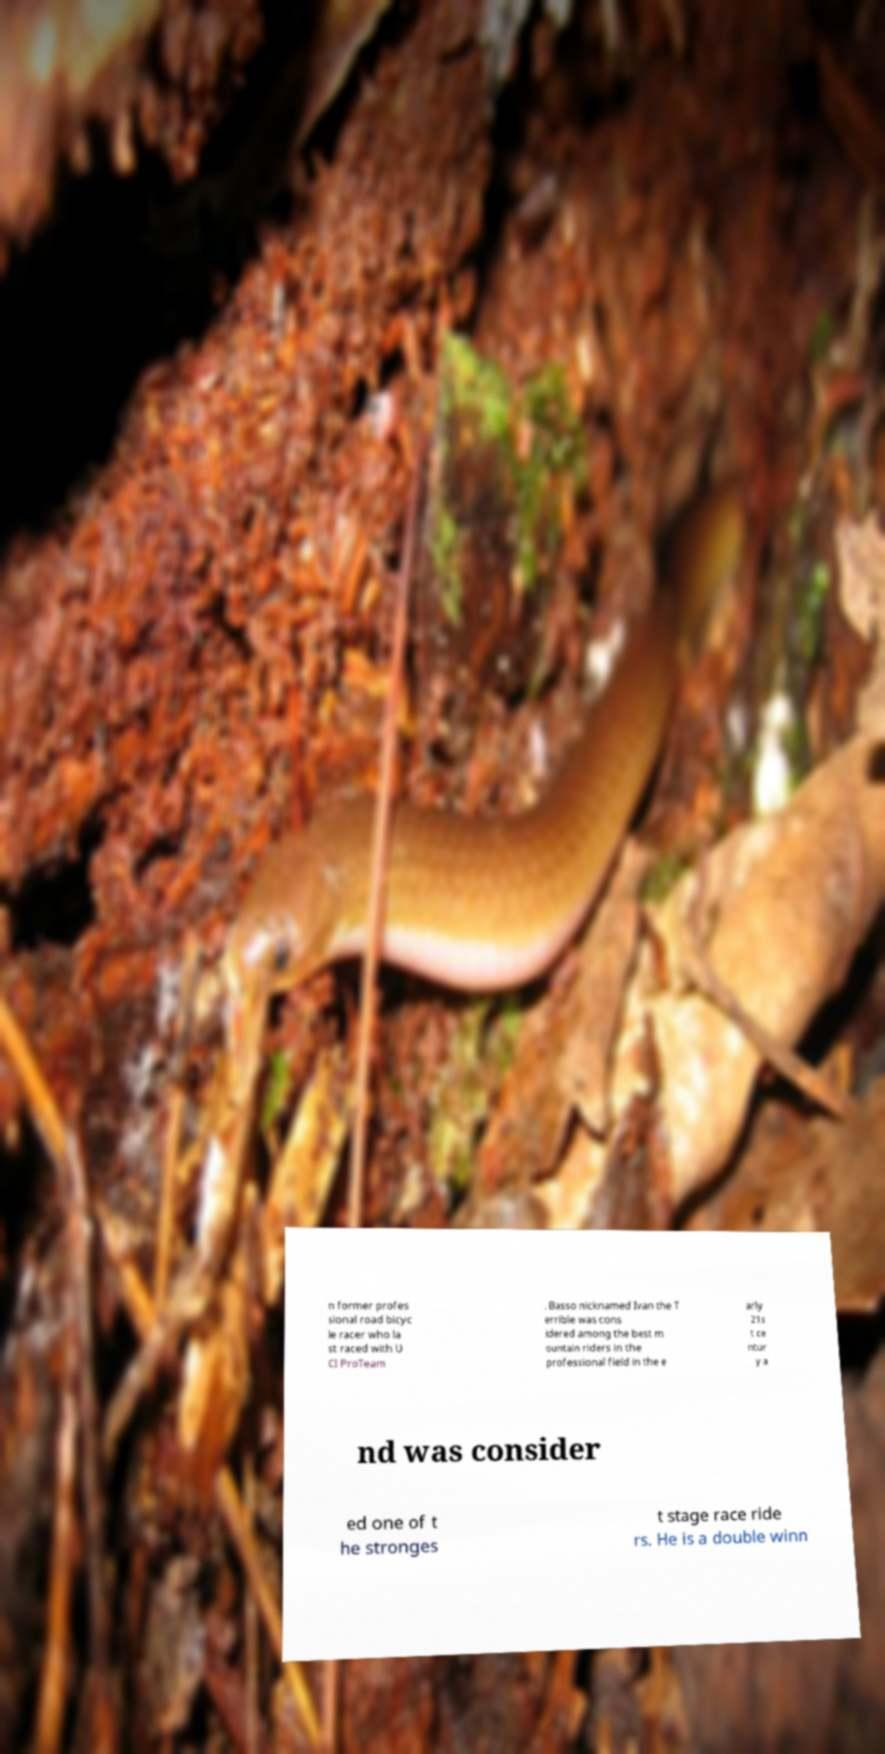For documentation purposes, I need the text within this image transcribed. Could you provide that? n former profes sional road bicyc le racer who la st raced with U CI ProTeam . Basso nicknamed Ivan the T errible was cons idered among the best m ountain riders in the professional field in the e arly 21s t ce ntur y a nd was consider ed one of t he stronges t stage race ride rs. He is a double winn 